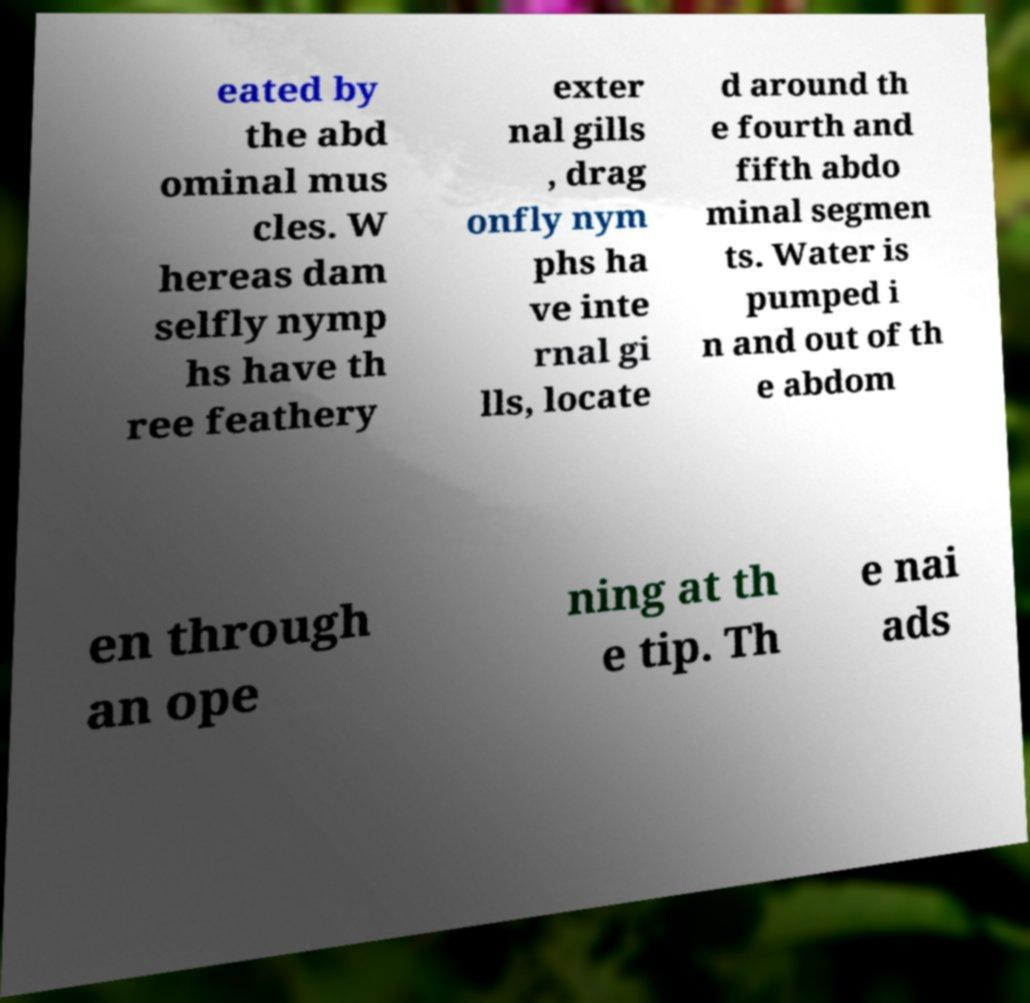For documentation purposes, I need the text within this image transcribed. Could you provide that? eated by the abd ominal mus cles. W hereas dam selfly nymp hs have th ree feathery exter nal gills , drag onfly nym phs ha ve inte rnal gi lls, locate d around th e fourth and fifth abdo minal segmen ts. Water is pumped i n and out of th e abdom en through an ope ning at th e tip. Th e nai ads 